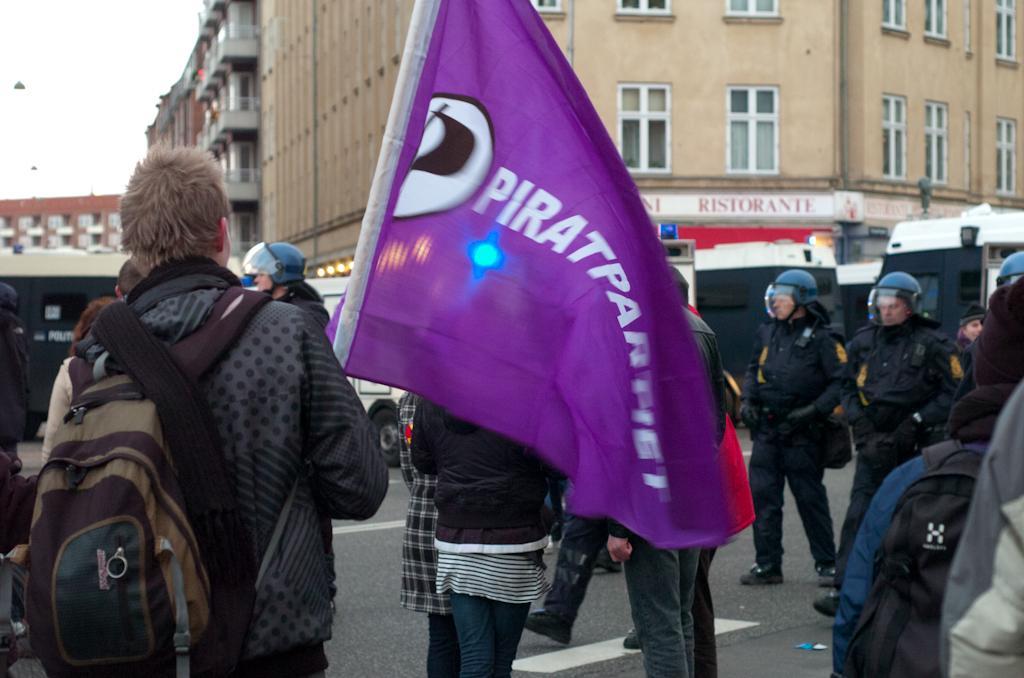Please provide a concise description of this image. In this image, we can see persons wearing clothes. There is a person on the left side of the image wearing bag and holding a flag with his hand. There is a building at the top of the image. 